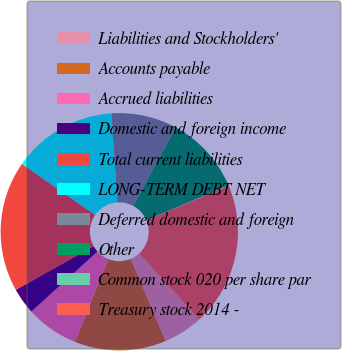Convert chart. <chart><loc_0><loc_0><loc_500><loc_500><pie_chart><fcel>Liabilities and Stockholders'<fcel>Accounts payable<fcel>Accrued liabilities<fcel>Domestic and foreign income<fcel>Total current liabilities<fcel>LONG-TERM DEBT NET<fcel>Deferred domestic and foreign<fcel>Other<fcel>Common stock 020 per share par<fcel>Treasury stock 2014 -<nl><fcel>5.38%<fcel>12.49%<fcel>7.16%<fcel>3.61%<fcel>17.81%<fcel>14.26%<fcel>8.93%<fcel>10.71%<fcel>0.06%<fcel>19.59%<nl></chart> 